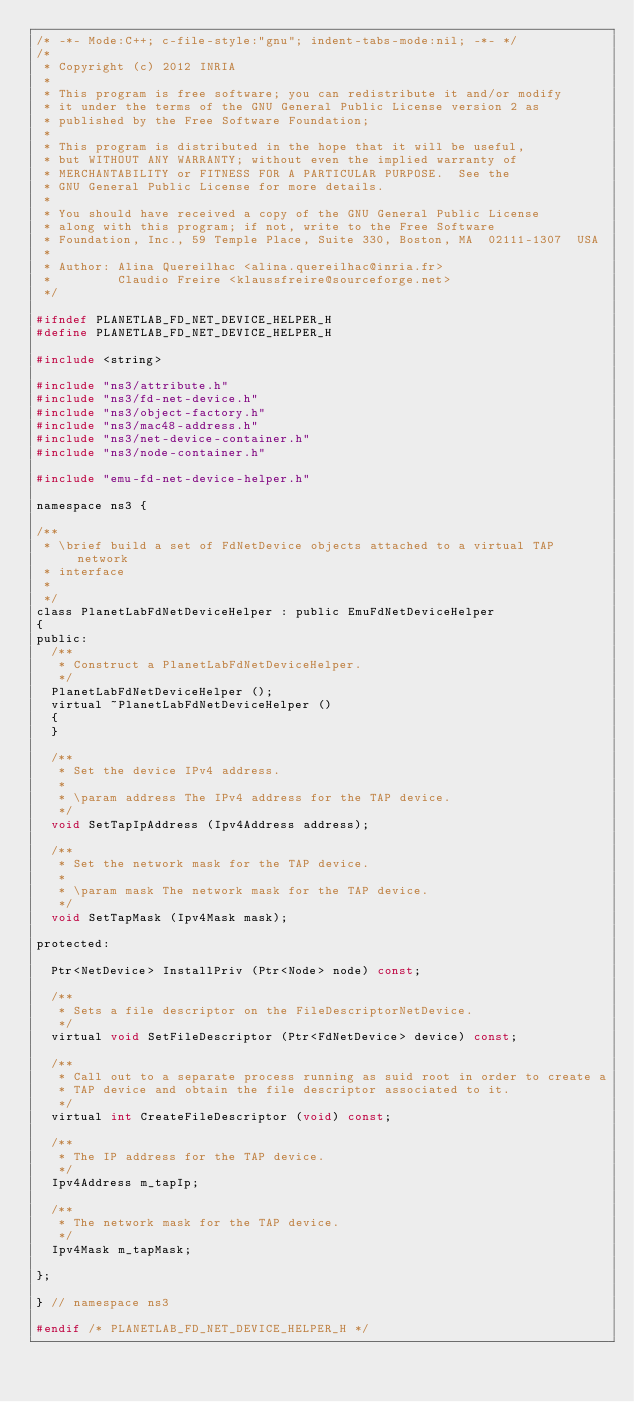<code> <loc_0><loc_0><loc_500><loc_500><_C_>/* -*- Mode:C++; c-file-style:"gnu"; indent-tabs-mode:nil; -*- */
/*
 * Copyright (c) 2012 INRIA
 *
 * This program is free software; you can redistribute it and/or modify
 * it under the terms of the GNU General Public License version 2 as
 * published by the Free Software Foundation;
 *
 * This program is distributed in the hope that it will be useful,
 * but WITHOUT ANY WARRANTY; without even the implied warranty of
 * MERCHANTABILITY or FITNESS FOR A PARTICULAR PURPOSE.  See the
 * GNU General Public License for more details.
 *
 * You should have received a copy of the GNU General Public License
 * along with this program; if not, write to the Free Software
 * Foundation, Inc., 59 Temple Place, Suite 330, Boston, MA  02111-1307  USA
 *
 * Author: Alina Quereilhac <alina.quereilhac@inria.fr>
 *         Claudio Freire <klaussfreire@sourceforge.net>
 */

#ifndef PLANETLAB_FD_NET_DEVICE_HELPER_H
#define PLANETLAB_FD_NET_DEVICE_HELPER_H

#include <string>

#include "ns3/attribute.h"
#include "ns3/fd-net-device.h"
#include "ns3/object-factory.h"
#include "ns3/mac48-address.h"
#include "ns3/net-device-container.h"
#include "ns3/node-container.h"

#include "emu-fd-net-device-helper.h"

namespace ns3 {

/**
 * \brief build a set of FdNetDevice objects attached to a virtual TAP network
 * interface
 *
 */
class PlanetLabFdNetDeviceHelper : public EmuFdNetDeviceHelper
{
public:
  /**
   * Construct a PlanetLabFdNetDeviceHelper.
   */
  PlanetLabFdNetDeviceHelper ();
  virtual ~PlanetLabFdNetDeviceHelper ()
  {
  }

  /**
   * Set the device IPv4 address.
   *
   * \param address The IPv4 address for the TAP device.
   */
  void SetTapIpAddress (Ipv4Address address);

  /**
   * Set the network mask for the TAP device.
   *
   * \param mask The network mask for the TAP device.
   */
  void SetTapMask (Ipv4Mask mask);

protected:

  Ptr<NetDevice> InstallPriv (Ptr<Node> node) const;

  /**
   * Sets a file descriptor on the FileDescriptorNetDevice.
   */
  virtual void SetFileDescriptor (Ptr<FdNetDevice> device) const;

  /**
   * Call out to a separate process running as suid root in order to create a
   * TAP device and obtain the file descriptor associated to it.
   */
  virtual int CreateFileDescriptor (void) const;

  /**
   * The IP address for the TAP device.
   */
  Ipv4Address m_tapIp;

  /**
   * The network mask for the TAP device.
   */
  Ipv4Mask m_tapMask;

};

} // namespace ns3

#endif /* PLANETLAB_FD_NET_DEVICE_HELPER_H */
</code> 